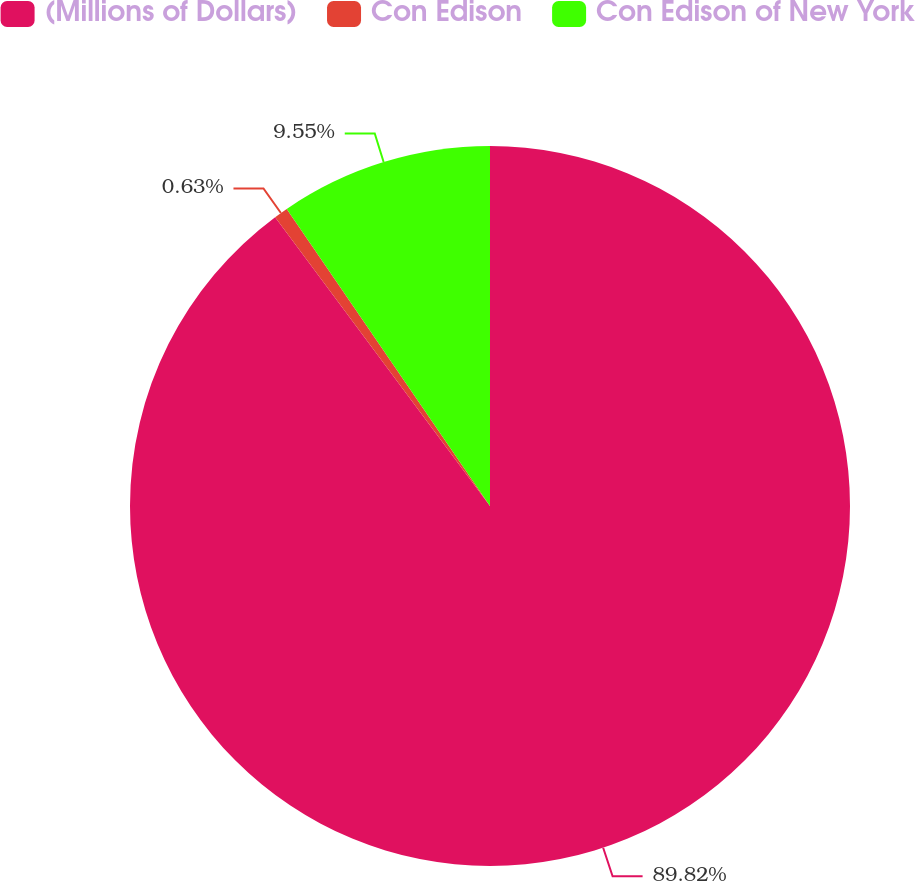<chart> <loc_0><loc_0><loc_500><loc_500><pie_chart><fcel>(Millions of Dollars)<fcel>Con Edison<fcel>Con Edison of New York<nl><fcel>89.83%<fcel>0.63%<fcel>9.55%<nl></chart> 